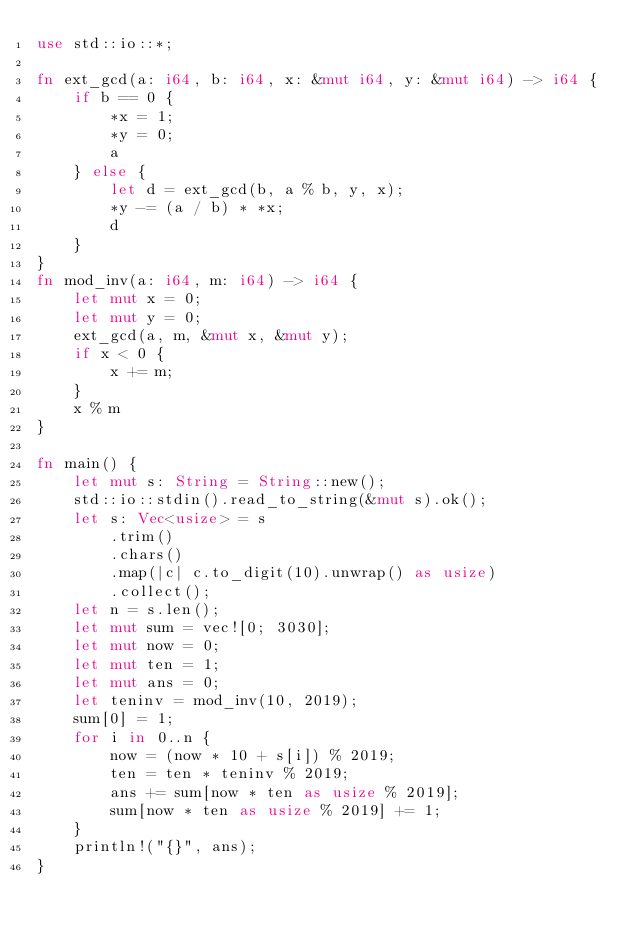Convert code to text. <code><loc_0><loc_0><loc_500><loc_500><_Rust_>use std::io::*;

fn ext_gcd(a: i64, b: i64, x: &mut i64, y: &mut i64) -> i64 {
    if b == 0 {
        *x = 1;
        *y = 0;
        a
    } else {
        let d = ext_gcd(b, a % b, y, x);
        *y -= (a / b) * *x;
        d
    }
}
fn mod_inv(a: i64, m: i64) -> i64 {
    let mut x = 0;
    let mut y = 0;
    ext_gcd(a, m, &mut x, &mut y);
    if x < 0 {
        x += m;
    }
    x % m
}

fn main() {
    let mut s: String = String::new();
    std::io::stdin().read_to_string(&mut s).ok();
    let s: Vec<usize> = s
        .trim()
        .chars()
        .map(|c| c.to_digit(10).unwrap() as usize)
        .collect();
    let n = s.len();
    let mut sum = vec![0; 3030];
    let mut now = 0;
    let mut ten = 1;
    let mut ans = 0;
    let teninv = mod_inv(10, 2019);
    sum[0] = 1;
    for i in 0..n {
        now = (now * 10 + s[i]) % 2019;
        ten = ten * teninv % 2019;
        ans += sum[now * ten as usize % 2019];
        sum[now * ten as usize % 2019] += 1;
    }
    println!("{}", ans);
}
</code> 